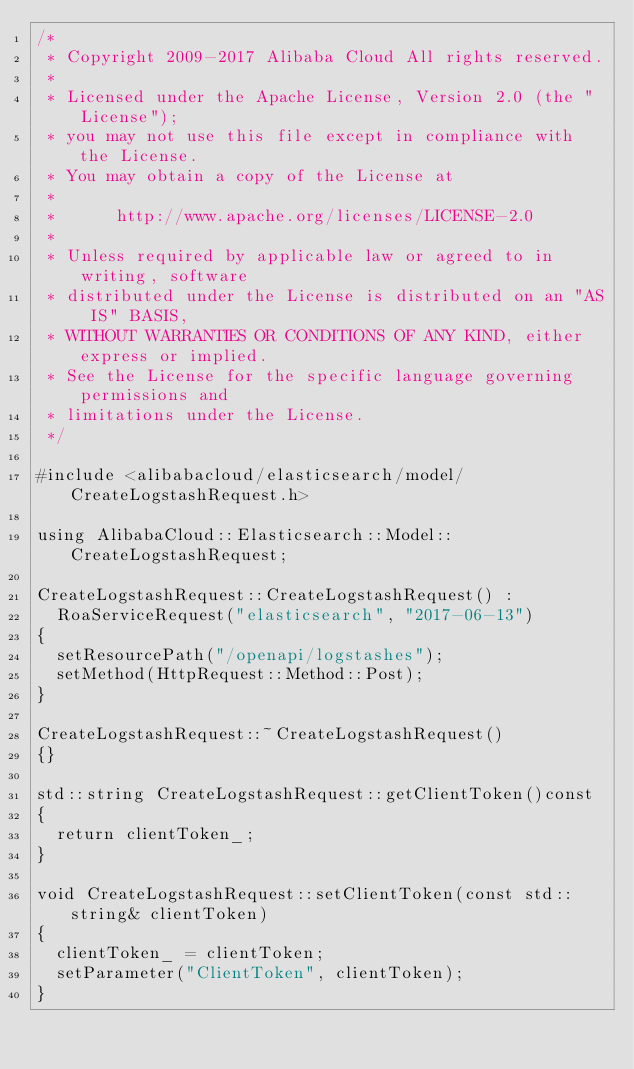Convert code to text. <code><loc_0><loc_0><loc_500><loc_500><_C++_>/*
 * Copyright 2009-2017 Alibaba Cloud All rights reserved.
 * 
 * Licensed under the Apache License, Version 2.0 (the "License");
 * you may not use this file except in compliance with the License.
 * You may obtain a copy of the License at
 * 
 *      http://www.apache.org/licenses/LICENSE-2.0
 * 
 * Unless required by applicable law or agreed to in writing, software
 * distributed under the License is distributed on an "AS IS" BASIS,
 * WITHOUT WARRANTIES OR CONDITIONS OF ANY KIND, either express or implied.
 * See the License for the specific language governing permissions and
 * limitations under the License.
 */

#include <alibabacloud/elasticsearch/model/CreateLogstashRequest.h>

using AlibabaCloud::Elasticsearch::Model::CreateLogstashRequest;

CreateLogstashRequest::CreateLogstashRequest() :
	RoaServiceRequest("elasticsearch", "2017-06-13")
{
	setResourcePath("/openapi/logstashes");
	setMethod(HttpRequest::Method::Post);
}

CreateLogstashRequest::~CreateLogstashRequest()
{}

std::string CreateLogstashRequest::getClientToken()const
{
	return clientToken_;
}

void CreateLogstashRequest::setClientToken(const std::string& clientToken)
{
	clientToken_ = clientToken;
	setParameter("ClientToken", clientToken);
}

</code> 